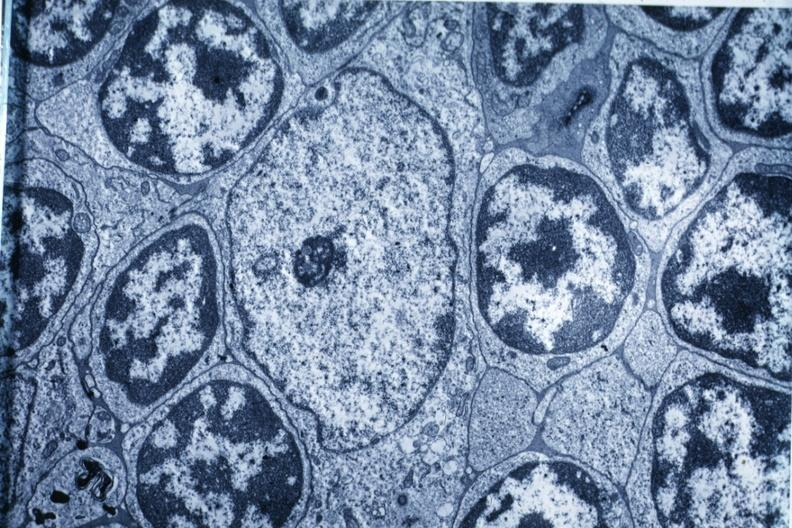s hematologic present?
Answer the question using a single word or phrase. Yes 